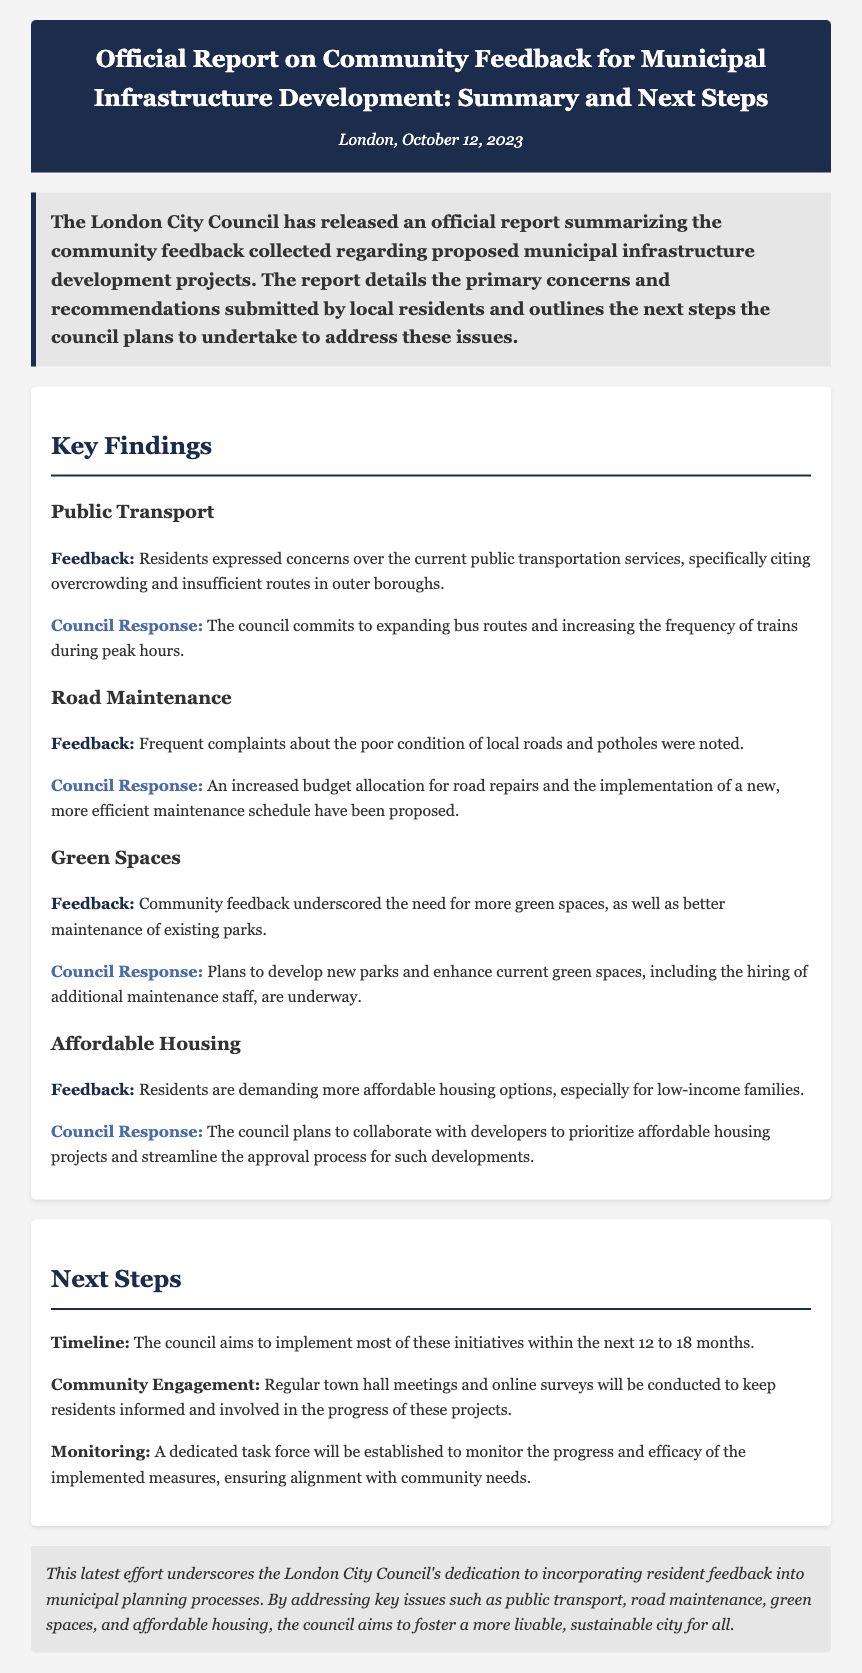What date was the press release published? The date of the press release is clearly stated at the top of the document under the header.
Answer: October 12, 2023 What is the primary focus of the report? The main theme of the report is mentioned in the lead paragraph, highlighting community feedback on municipal infrastructure.
Answer: Community feedback How long does the council plan to take for implementing the initiatives? The timeline for implementation is mentioned in the section on next steps, specifying the duration for these initiatives.
Answer: 12 to 18 months Which area did residents express concerns over regarding public transport? The feedback section lists specific areas of concern, and public transport issues are addressed under that section.
Answer: Overcrowding and insufficient routes What is one of the proposed measures for road maintenance? The response to the feedback on road maintenance includes specific proposals that reflect the council's commitment to addressing the issue.
Answer: Increased budget allocation What type of meetings will the council conduct for community engagement? The next steps section discusses how the council plans to keep the community involved, mentioning the types of meetings to be held.
Answer: Town hall meetings What is the council planning to prioritize regarding affordable housing? The response regarding affordable housing specifies an intention related to development collaboration and project emphasis.
Answer: Collaborate with developers What will be established to monitor the progress of initiatives? The next steps section outlines measures to ensure accountability and proper tracking of the initiatives.
Answer: A dedicated task force 